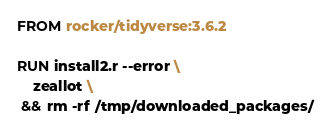<code> <loc_0><loc_0><loc_500><loc_500><_Dockerfile_>FROM rocker/tidyverse:3.6.2

RUN install2.r --error \
    zeallot \
 && rm -rf /tmp/downloaded_packages/
</code> 